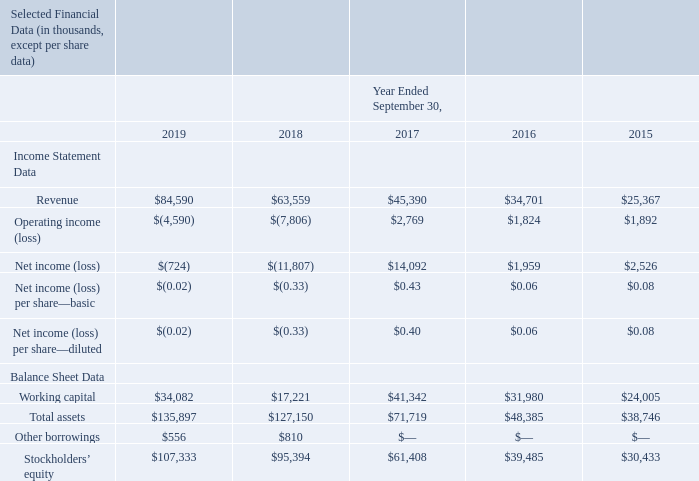ITEM 6. SELECTED FINANCIAL DATA.
The following selected financial data has been derived from our audited financial statements. This data should be read in conjunction with Item 7— “Management’s Discussion and Analysis of Financial Condition and Results of Operations” and our financial statements and related notes thereto included elsewhere in this Form 10-K. Our historical results are not necessarily indicative of operating results to be expected in the future.
What does the table show us? Selected financial data has been derived from our audited financial statements. How should the table be read together with? Item 7— “management’s discussion and analysis of financial condition and results of operations” and our financial statements and related notes thereto included elsewhere in this form 10-k. How much were the revenues from 2015 to 2019 respectively?
Answer scale should be: thousand. $25,367, $34,701, $45,390, $63,559, $84,590. What is the percentage change in working capital from 2018 to 2019?
Answer scale should be: percent. (34,082-17,221)/17,221 
Answer: 97.91. In which year did the company earn the highest net income? $ 14,092>$ 2,526>$ 1,959>$ (724)> $ (11,807)
Answer: 2017. What is the average total assets for the last 5 years, i.e. 2015 to 2019?
Answer scale should be: thousand. (135,897+127,150+71,719+48,385+38,746)/5 
Answer: 84379.4. 